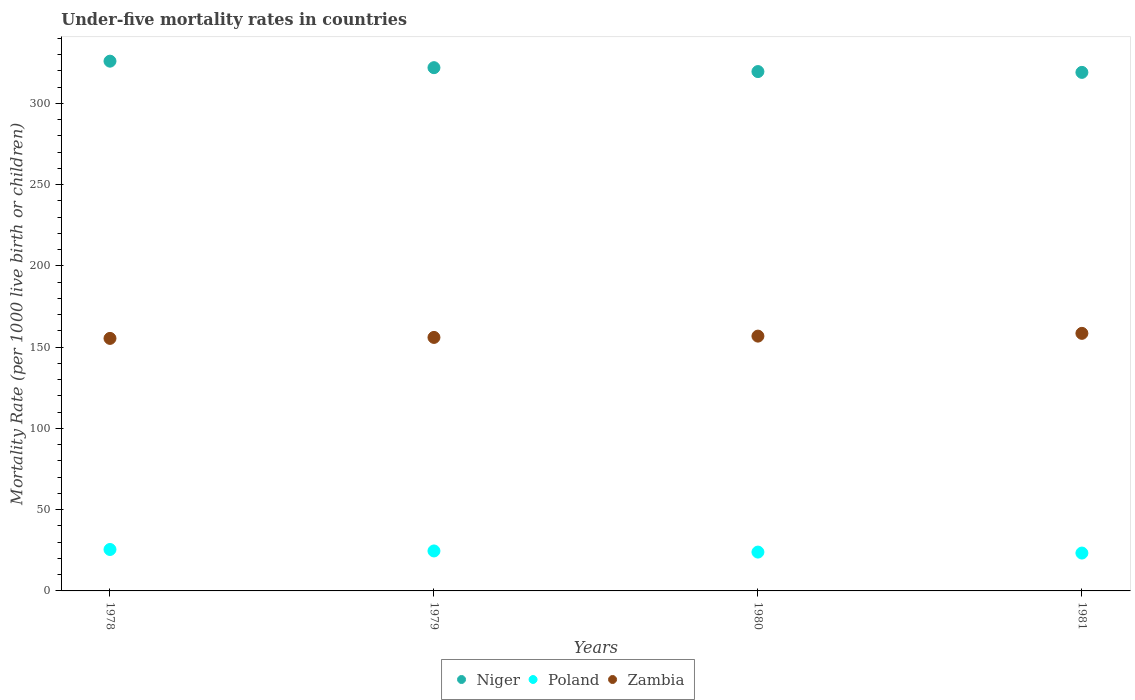How many different coloured dotlines are there?
Your answer should be compact. 3. What is the under-five mortality rate in Niger in 1979?
Offer a very short reply. 322. Across all years, what is the maximum under-five mortality rate in Niger?
Make the answer very short. 326. Across all years, what is the minimum under-five mortality rate in Poland?
Offer a very short reply. 23.3. In which year was the under-five mortality rate in Niger maximum?
Keep it short and to the point. 1978. In which year was the under-five mortality rate in Niger minimum?
Provide a succinct answer. 1981. What is the total under-five mortality rate in Poland in the graph?
Your answer should be very brief. 97.3. What is the difference between the under-five mortality rate in Niger in 1979 and that in 1980?
Give a very brief answer. 2.4. What is the difference between the under-five mortality rate in Poland in 1978 and the under-five mortality rate in Zambia in 1980?
Keep it short and to the point. -131.3. What is the average under-five mortality rate in Zambia per year?
Give a very brief answer. 156.68. In the year 1981, what is the difference between the under-five mortality rate in Zambia and under-five mortality rate in Niger?
Offer a very short reply. -160.6. In how many years, is the under-five mortality rate in Niger greater than 80?
Ensure brevity in your answer.  4. What is the ratio of the under-five mortality rate in Niger in 1978 to that in 1981?
Offer a terse response. 1.02. What is the difference between the highest and the second highest under-five mortality rate in Niger?
Your answer should be compact. 4. What is the difference between the highest and the lowest under-five mortality rate in Zambia?
Provide a short and direct response. 3.1. In how many years, is the under-five mortality rate in Poland greater than the average under-five mortality rate in Poland taken over all years?
Ensure brevity in your answer.  2. Is it the case that in every year, the sum of the under-five mortality rate in Niger and under-five mortality rate in Poland  is greater than the under-five mortality rate in Zambia?
Give a very brief answer. Yes. Does the under-five mortality rate in Zambia monotonically increase over the years?
Keep it short and to the point. Yes. Is the under-five mortality rate in Zambia strictly greater than the under-five mortality rate in Poland over the years?
Your answer should be very brief. Yes. Is the under-five mortality rate in Zambia strictly less than the under-five mortality rate in Niger over the years?
Ensure brevity in your answer.  Yes. What is the difference between two consecutive major ticks on the Y-axis?
Make the answer very short. 50. Are the values on the major ticks of Y-axis written in scientific E-notation?
Give a very brief answer. No. Does the graph contain any zero values?
Offer a very short reply. No. Does the graph contain grids?
Offer a very short reply. No. What is the title of the graph?
Make the answer very short. Under-five mortality rates in countries. Does "Kosovo" appear as one of the legend labels in the graph?
Make the answer very short. No. What is the label or title of the Y-axis?
Offer a very short reply. Mortality Rate (per 1000 live birth or children). What is the Mortality Rate (per 1000 live birth or children) in Niger in 1978?
Ensure brevity in your answer.  326. What is the Mortality Rate (per 1000 live birth or children) of Zambia in 1978?
Keep it short and to the point. 155.4. What is the Mortality Rate (per 1000 live birth or children) in Niger in 1979?
Provide a succinct answer. 322. What is the Mortality Rate (per 1000 live birth or children) of Poland in 1979?
Keep it short and to the point. 24.6. What is the Mortality Rate (per 1000 live birth or children) in Zambia in 1979?
Offer a terse response. 156. What is the Mortality Rate (per 1000 live birth or children) in Niger in 1980?
Your answer should be compact. 319.6. What is the Mortality Rate (per 1000 live birth or children) in Poland in 1980?
Your answer should be very brief. 23.9. What is the Mortality Rate (per 1000 live birth or children) of Zambia in 1980?
Keep it short and to the point. 156.8. What is the Mortality Rate (per 1000 live birth or children) of Niger in 1981?
Provide a short and direct response. 319.1. What is the Mortality Rate (per 1000 live birth or children) in Poland in 1981?
Offer a terse response. 23.3. What is the Mortality Rate (per 1000 live birth or children) in Zambia in 1981?
Your response must be concise. 158.5. Across all years, what is the maximum Mortality Rate (per 1000 live birth or children) in Niger?
Give a very brief answer. 326. Across all years, what is the maximum Mortality Rate (per 1000 live birth or children) in Poland?
Give a very brief answer. 25.5. Across all years, what is the maximum Mortality Rate (per 1000 live birth or children) of Zambia?
Offer a terse response. 158.5. Across all years, what is the minimum Mortality Rate (per 1000 live birth or children) in Niger?
Provide a short and direct response. 319.1. Across all years, what is the minimum Mortality Rate (per 1000 live birth or children) of Poland?
Make the answer very short. 23.3. Across all years, what is the minimum Mortality Rate (per 1000 live birth or children) of Zambia?
Provide a short and direct response. 155.4. What is the total Mortality Rate (per 1000 live birth or children) of Niger in the graph?
Your response must be concise. 1286.7. What is the total Mortality Rate (per 1000 live birth or children) in Poland in the graph?
Offer a terse response. 97.3. What is the total Mortality Rate (per 1000 live birth or children) of Zambia in the graph?
Give a very brief answer. 626.7. What is the difference between the Mortality Rate (per 1000 live birth or children) in Niger in 1978 and that in 1979?
Provide a succinct answer. 4. What is the difference between the Mortality Rate (per 1000 live birth or children) of Poland in 1978 and that in 1979?
Ensure brevity in your answer.  0.9. What is the difference between the Mortality Rate (per 1000 live birth or children) in Niger in 1978 and that in 1980?
Your answer should be compact. 6.4. What is the difference between the Mortality Rate (per 1000 live birth or children) in Poland in 1978 and that in 1980?
Provide a succinct answer. 1.6. What is the difference between the Mortality Rate (per 1000 live birth or children) of Zambia in 1978 and that in 1980?
Your answer should be compact. -1.4. What is the difference between the Mortality Rate (per 1000 live birth or children) in Niger in 1978 and that in 1981?
Provide a succinct answer. 6.9. What is the difference between the Mortality Rate (per 1000 live birth or children) in Poland in 1978 and that in 1981?
Keep it short and to the point. 2.2. What is the difference between the Mortality Rate (per 1000 live birth or children) of Niger in 1979 and that in 1980?
Give a very brief answer. 2.4. What is the difference between the Mortality Rate (per 1000 live birth or children) of Niger in 1980 and that in 1981?
Ensure brevity in your answer.  0.5. What is the difference between the Mortality Rate (per 1000 live birth or children) in Zambia in 1980 and that in 1981?
Your answer should be very brief. -1.7. What is the difference between the Mortality Rate (per 1000 live birth or children) of Niger in 1978 and the Mortality Rate (per 1000 live birth or children) of Poland in 1979?
Keep it short and to the point. 301.4. What is the difference between the Mortality Rate (per 1000 live birth or children) of Niger in 1978 and the Mortality Rate (per 1000 live birth or children) of Zambia in 1979?
Ensure brevity in your answer.  170. What is the difference between the Mortality Rate (per 1000 live birth or children) of Poland in 1978 and the Mortality Rate (per 1000 live birth or children) of Zambia in 1979?
Provide a short and direct response. -130.5. What is the difference between the Mortality Rate (per 1000 live birth or children) of Niger in 1978 and the Mortality Rate (per 1000 live birth or children) of Poland in 1980?
Keep it short and to the point. 302.1. What is the difference between the Mortality Rate (per 1000 live birth or children) in Niger in 1978 and the Mortality Rate (per 1000 live birth or children) in Zambia in 1980?
Give a very brief answer. 169.2. What is the difference between the Mortality Rate (per 1000 live birth or children) in Poland in 1978 and the Mortality Rate (per 1000 live birth or children) in Zambia in 1980?
Keep it short and to the point. -131.3. What is the difference between the Mortality Rate (per 1000 live birth or children) of Niger in 1978 and the Mortality Rate (per 1000 live birth or children) of Poland in 1981?
Keep it short and to the point. 302.7. What is the difference between the Mortality Rate (per 1000 live birth or children) in Niger in 1978 and the Mortality Rate (per 1000 live birth or children) in Zambia in 1981?
Your answer should be compact. 167.5. What is the difference between the Mortality Rate (per 1000 live birth or children) of Poland in 1978 and the Mortality Rate (per 1000 live birth or children) of Zambia in 1981?
Provide a short and direct response. -133. What is the difference between the Mortality Rate (per 1000 live birth or children) in Niger in 1979 and the Mortality Rate (per 1000 live birth or children) in Poland in 1980?
Your answer should be compact. 298.1. What is the difference between the Mortality Rate (per 1000 live birth or children) of Niger in 1979 and the Mortality Rate (per 1000 live birth or children) of Zambia in 1980?
Keep it short and to the point. 165.2. What is the difference between the Mortality Rate (per 1000 live birth or children) in Poland in 1979 and the Mortality Rate (per 1000 live birth or children) in Zambia in 1980?
Keep it short and to the point. -132.2. What is the difference between the Mortality Rate (per 1000 live birth or children) of Niger in 1979 and the Mortality Rate (per 1000 live birth or children) of Poland in 1981?
Keep it short and to the point. 298.7. What is the difference between the Mortality Rate (per 1000 live birth or children) of Niger in 1979 and the Mortality Rate (per 1000 live birth or children) of Zambia in 1981?
Your answer should be very brief. 163.5. What is the difference between the Mortality Rate (per 1000 live birth or children) in Poland in 1979 and the Mortality Rate (per 1000 live birth or children) in Zambia in 1981?
Offer a very short reply. -133.9. What is the difference between the Mortality Rate (per 1000 live birth or children) in Niger in 1980 and the Mortality Rate (per 1000 live birth or children) in Poland in 1981?
Offer a terse response. 296.3. What is the difference between the Mortality Rate (per 1000 live birth or children) of Niger in 1980 and the Mortality Rate (per 1000 live birth or children) of Zambia in 1981?
Keep it short and to the point. 161.1. What is the difference between the Mortality Rate (per 1000 live birth or children) in Poland in 1980 and the Mortality Rate (per 1000 live birth or children) in Zambia in 1981?
Make the answer very short. -134.6. What is the average Mortality Rate (per 1000 live birth or children) in Niger per year?
Make the answer very short. 321.68. What is the average Mortality Rate (per 1000 live birth or children) in Poland per year?
Offer a terse response. 24.32. What is the average Mortality Rate (per 1000 live birth or children) of Zambia per year?
Make the answer very short. 156.68. In the year 1978, what is the difference between the Mortality Rate (per 1000 live birth or children) in Niger and Mortality Rate (per 1000 live birth or children) in Poland?
Offer a terse response. 300.5. In the year 1978, what is the difference between the Mortality Rate (per 1000 live birth or children) in Niger and Mortality Rate (per 1000 live birth or children) in Zambia?
Ensure brevity in your answer.  170.6. In the year 1978, what is the difference between the Mortality Rate (per 1000 live birth or children) in Poland and Mortality Rate (per 1000 live birth or children) in Zambia?
Provide a succinct answer. -129.9. In the year 1979, what is the difference between the Mortality Rate (per 1000 live birth or children) in Niger and Mortality Rate (per 1000 live birth or children) in Poland?
Your answer should be very brief. 297.4. In the year 1979, what is the difference between the Mortality Rate (per 1000 live birth or children) of Niger and Mortality Rate (per 1000 live birth or children) of Zambia?
Provide a succinct answer. 166. In the year 1979, what is the difference between the Mortality Rate (per 1000 live birth or children) of Poland and Mortality Rate (per 1000 live birth or children) of Zambia?
Keep it short and to the point. -131.4. In the year 1980, what is the difference between the Mortality Rate (per 1000 live birth or children) in Niger and Mortality Rate (per 1000 live birth or children) in Poland?
Your answer should be very brief. 295.7. In the year 1980, what is the difference between the Mortality Rate (per 1000 live birth or children) of Niger and Mortality Rate (per 1000 live birth or children) of Zambia?
Ensure brevity in your answer.  162.8. In the year 1980, what is the difference between the Mortality Rate (per 1000 live birth or children) in Poland and Mortality Rate (per 1000 live birth or children) in Zambia?
Offer a very short reply. -132.9. In the year 1981, what is the difference between the Mortality Rate (per 1000 live birth or children) in Niger and Mortality Rate (per 1000 live birth or children) in Poland?
Your answer should be very brief. 295.8. In the year 1981, what is the difference between the Mortality Rate (per 1000 live birth or children) of Niger and Mortality Rate (per 1000 live birth or children) of Zambia?
Offer a terse response. 160.6. In the year 1981, what is the difference between the Mortality Rate (per 1000 live birth or children) in Poland and Mortality Rate (per 1000 live birth or children) in Zambia?
Your response must be concise. -135.2. What is the ratio of the Mortality Rate (per 1000 live birth or children) of Niger in 1978 to that in 1979?
Ensure brevity in your answer.  1.01. What is the ratio of the Mortality Rate (per 1000 live birth or children) in Poland in 1978 to that in 1979?
Provide a succinct answer. 1.04. What is the ratio of the Mortality Rate (per 1000 live birth or children) of Niger in 1978 to that in 1980?
Make the answer very short. 1.02. What is the ratio of the Mortality Rate (per 1000 live birth or children) in Poland in 1978 to that in 1980?
Ensure brevity in your answer.  1.07. What is the ratio of the Mortality Rate (per 1000 live birth or children) in Niger in 1978 to that in 1981?
Your response must be concise. 1.02. What is the ratio of the Mortality Rate (per 1000 live birth or children) of Poland in 1978 to that in 1981?
Provide a succinct answer. 1.09. What is the ratio of the Mortality Rate (per 1000 live birth or children) in Zambia in 1978 to that in 1981?
Keep it short and to the point. 0.98. What is the ratio of the Mortality Rate (per 1000 live birth or children) of Niger in 1979 to that in 1980?
Ensure brevity in your answer.  1.01. What is the ratio of the Mortality Rate (per 1000 live birth or children) of Poland in 1979 to that in 1980?
Offer a terse response. 1.03. What is the ratio of the Mortality Rate (per 1000 live birth or children) in Zambia in 1979 to that in 1980?
Offer a very short reply. 0.99. What is the ratio of the Mortality Rate (per 1000 live birth or children) in Niger in 1979 to that in 1981?
Your response must be concise. 1.01. What is the ratio of the Mortality Rate (per 1000 live birth or children) in Poland in 1979 to that in 1981?
Offer a terse response. 1.06. What is the ratio of the Mortality Rate (per 1000 live birth or children) of Zambia in 1979 to that in 1981?
Make the answer very short. 0.98. What is the ratio of the Mortality Rate (per 1000 live birth or children) of Poland in 1980 to that in 1981?
Your answer should be compact. 1.03. What is the ratio of the Mortality Rate (per 1000 live birth or children) of Zambia in 1980 to that in 1981?
Offer a terse response. 0.99. What is the difference between the highest and the second highest Mortality Rate (per 1000 live birth or children) of Niger?
Provide a succinct answer. 4. What is the difference between the highest and the second highest Mortality Rate (per 1000 live birth or children) of Poland?
Ensure brevity in your answer.  0.9. What is the difference between the highest and the lowest Mortality Rate (per 1000 live birth or children) of Poland?
Offer a very short reply. 2.2. What is the difference between the highest and the lowest Mortality Rate (per 1000 live birth or children) of Zambia?
Your answer should be compact. 3.1. 